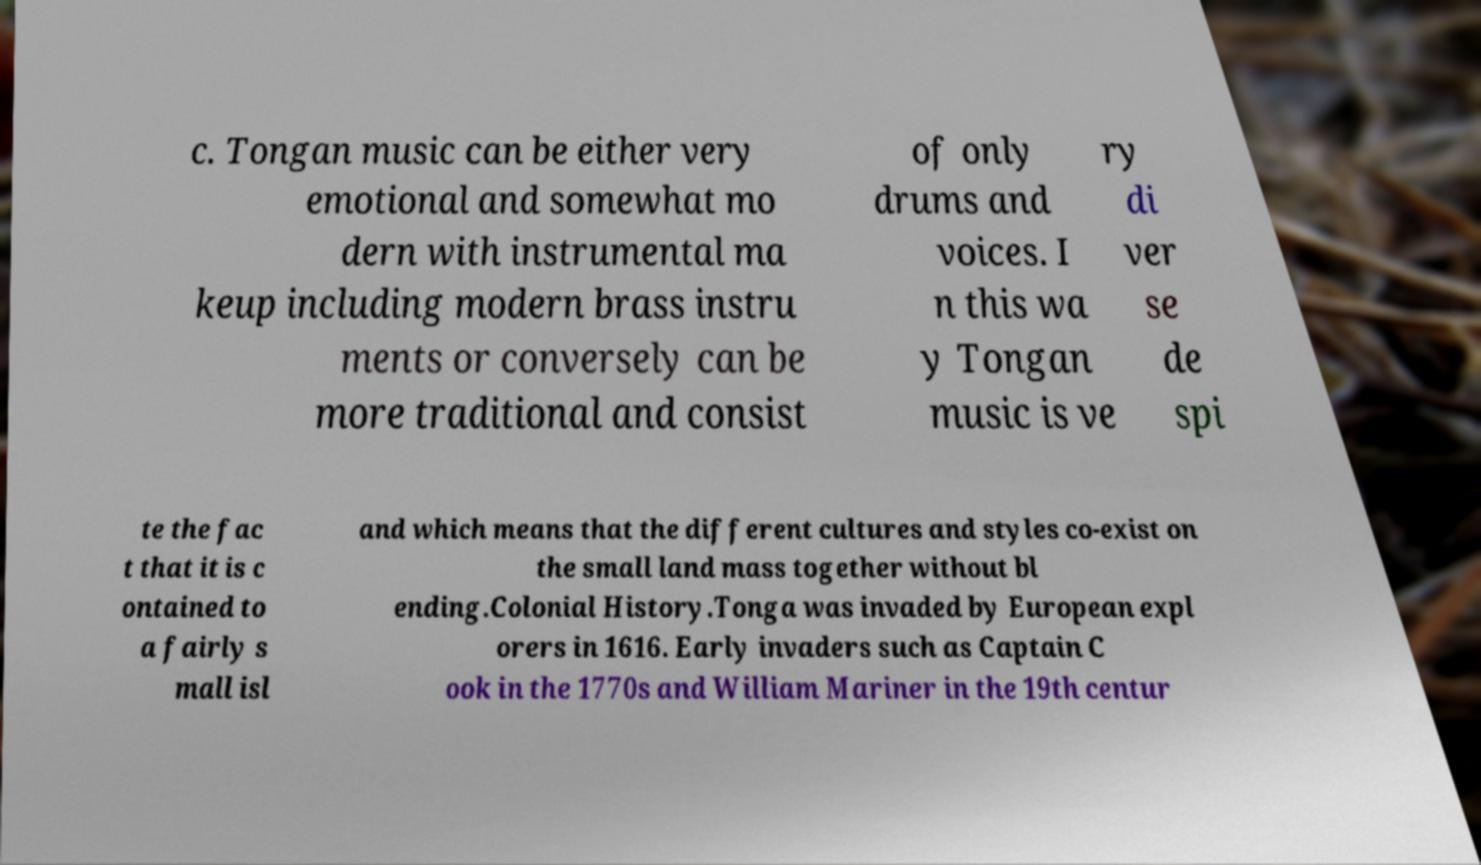I need the written content from this picture converted into text. Can you do that? c. Tongan music can be either very emotional and somewhat mo dern with instrumental ma keup including modern brass instru ments or conversely can be more traditional and consist of only drums and voices. I n this wa y Tongan music is ve ry di ver se de spi te the fac t that it is c ontained to a fairly s mall isl and which means that the different cultures and styles co-exist on the small land mass together without bl ending.Colonial History.Tonga was invaded by European expl orers in 1616. Early invaders such as Captain C ook in the 1770s and William Mariner in the 19th centur 